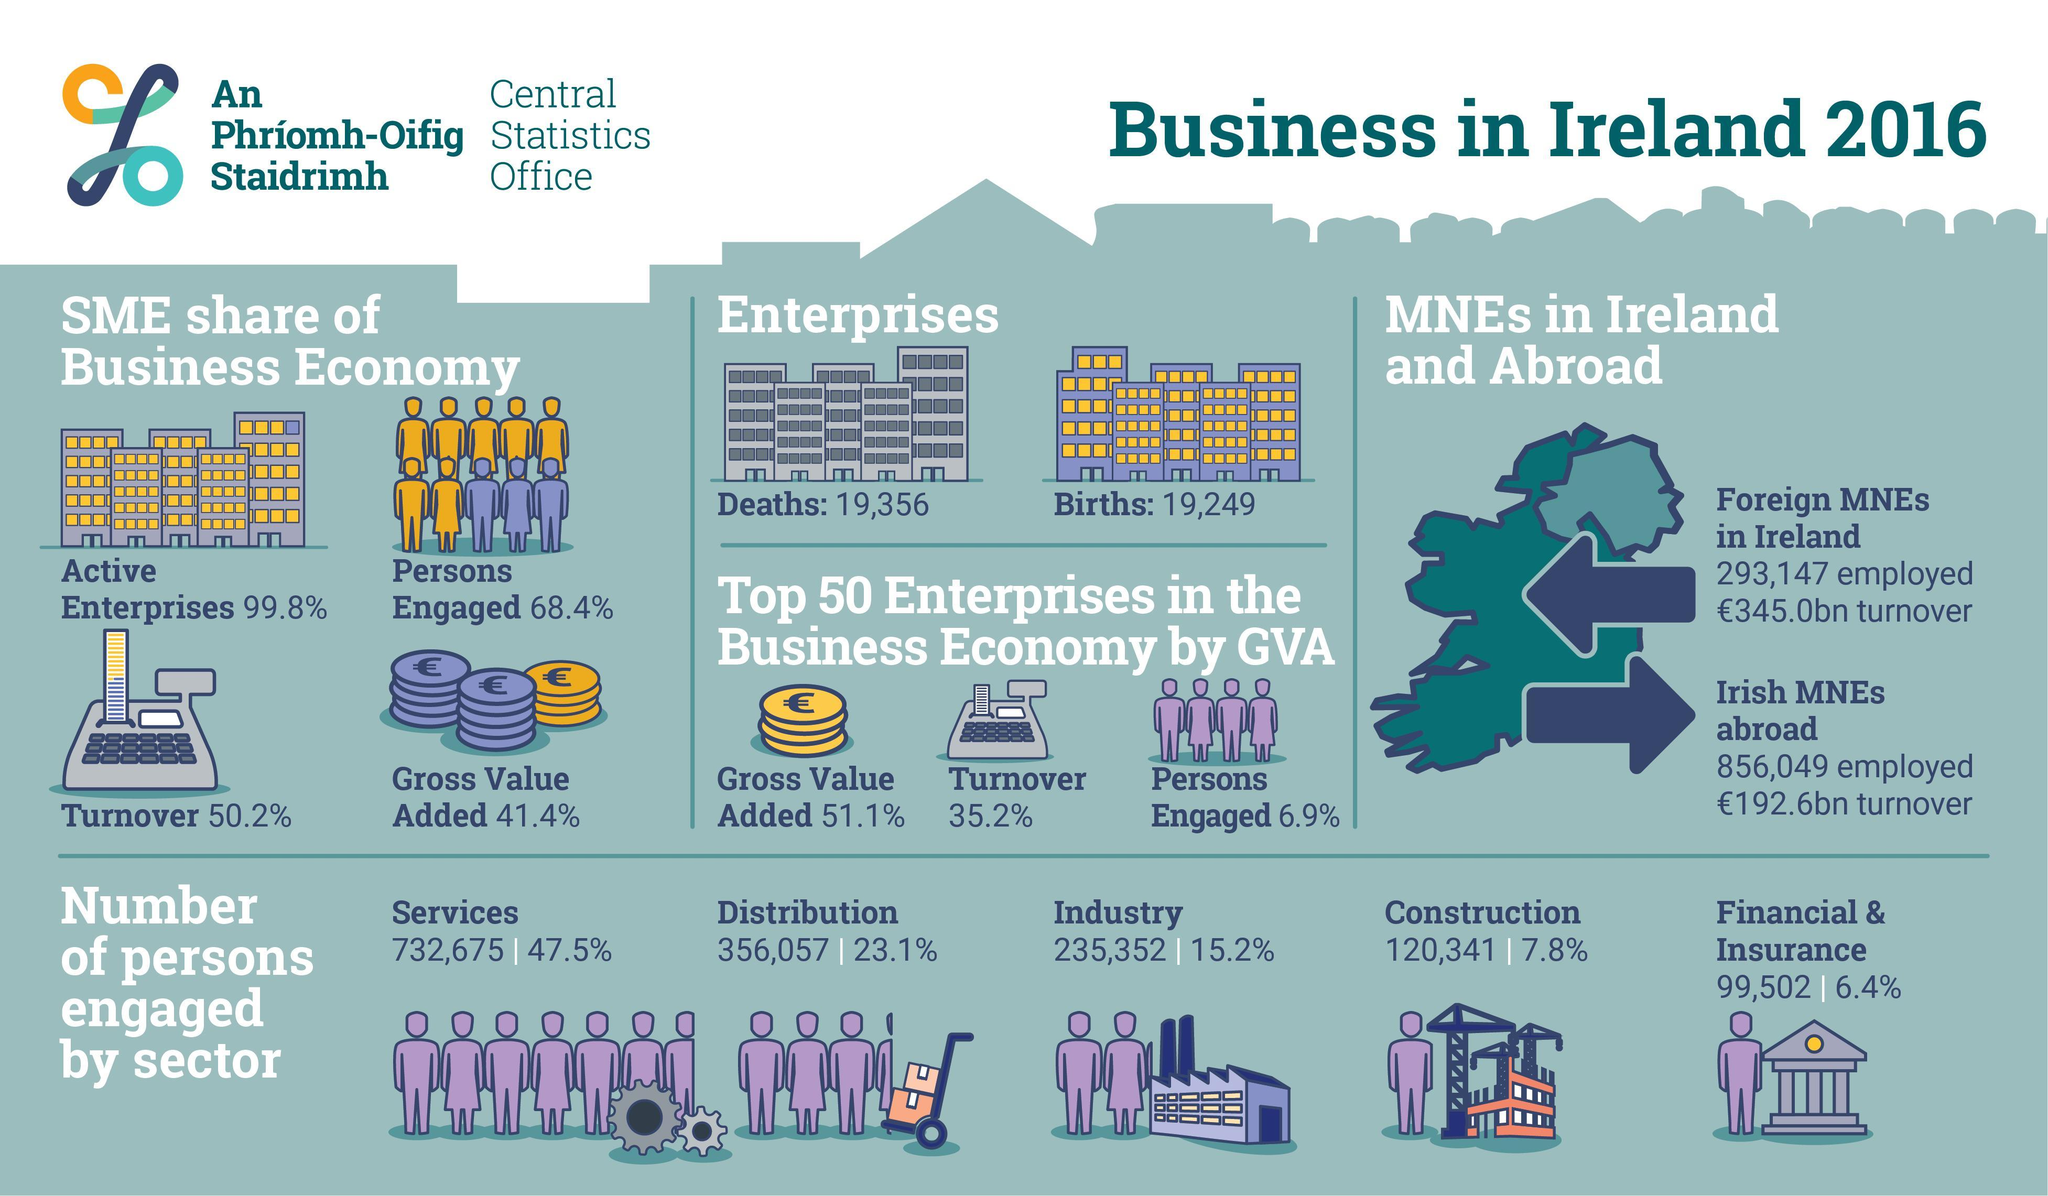in which sector is the third highest employee count
Answer the question with a short phrase. industry what is the difference between births and deaths of Enterprises 107 what is the number of people engaged in distribution and industry 591409 which MNE has a higher turnover Foreign MNEs in Ireland 